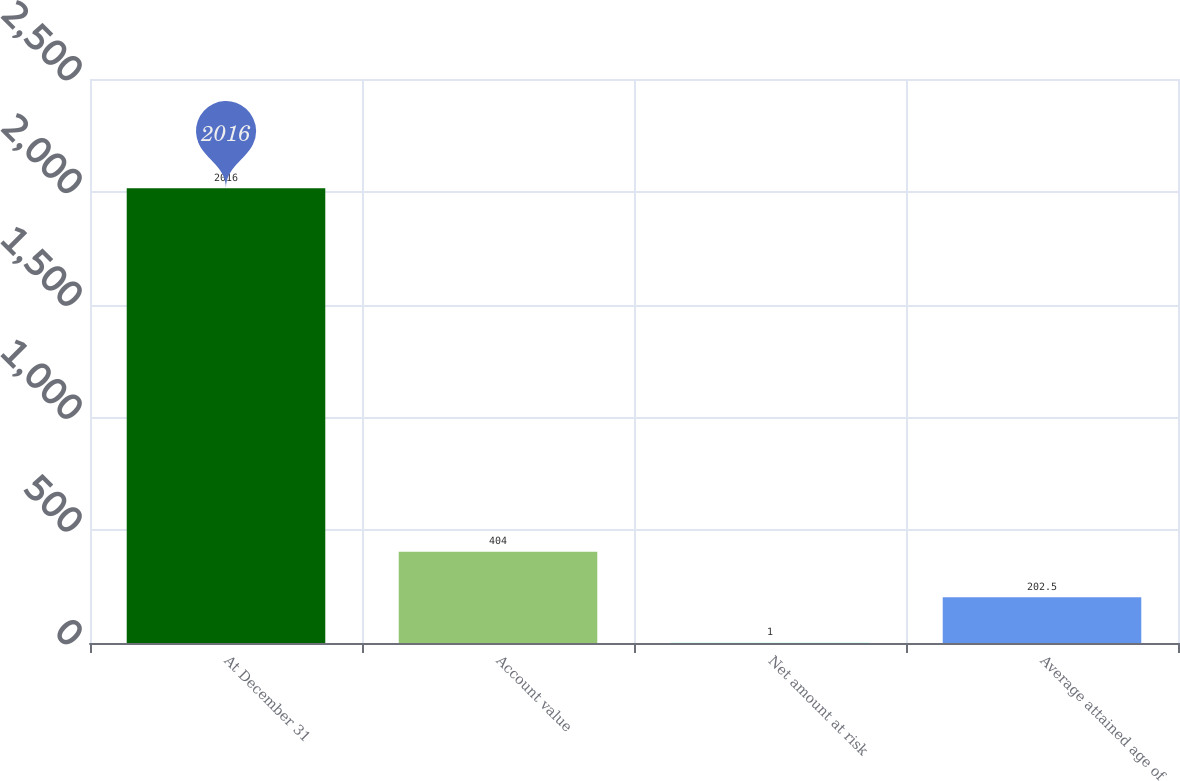Convert chart to OTSL. <chart><loc_0><loc_0><loc_500><loc_500><bar_chart><fcel>At December 31<fcel>Account value<fcel>Net amount at risk<fcel>Average attained age of<nl><fcel>2016<fcel>404<fcel>1<fcel>202.5<nl></chart> 